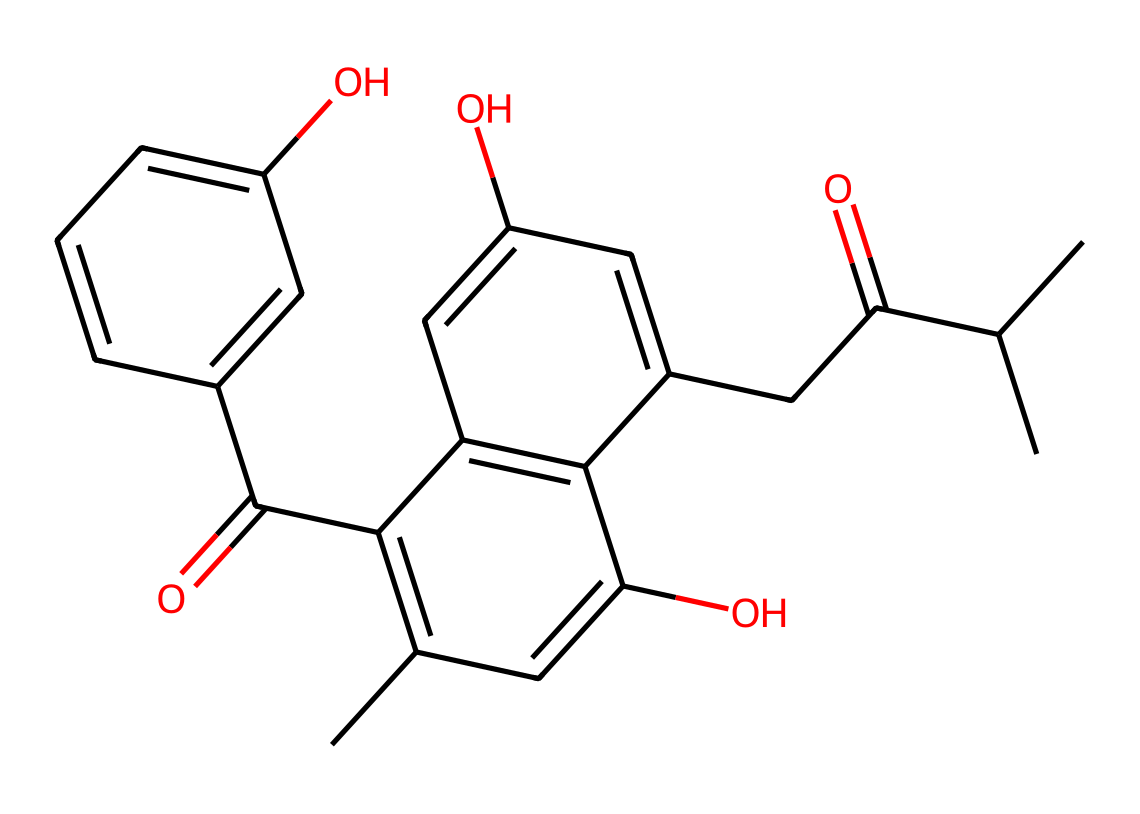What is the molecular formula of this chemical? The SMILES representation can be parsed to identify the atoms present. Counting the carbon (C), hydrogen (H), and oxygen (O) atoms shows that there are 21 carbon atoms, 30 hydrogen atoms, and 6 oxygen atoms. Thus, the molecular formula is C21H30O6.
Answer: C21H30O6 How many rings are present in the structure? By examining the structure found in the SMILES notation, it shows that there are two cyclic components present, which indicates two rings.
Answer: 2 What functional groups can be identified in this chemical? The chemical structure indicates the presence of hydroxy groups (-OH) and ketone groups (C=O). Observing the functional parts from the SMILES clarifies this.
Answer: hydroxy and ketone What type of drug classification does this chemical belong to? This compound has a structure characteristic of cannabinoids, primarily because it contains tetrahydrocannabinol. Its structure aligns with psychoactive substances affecting the nervous system.
Answer: cannabinoid How does this chemical impact perception? THC acts on cannabinoid receptors in the brain, influencing neurotransmitter release and altering various sensory perceptions such as pain, time, and space. This systemic interaction leads to changes in perception experienced by users.
Answer: alters perception What is the primary psychological effect associated with this drug? THC is known to induce euphoria and relaxation, often termed a “high.” This effect stems from its action on certain receptors in the brain that regulate mood and emotional responses.
Answer: euphoria 